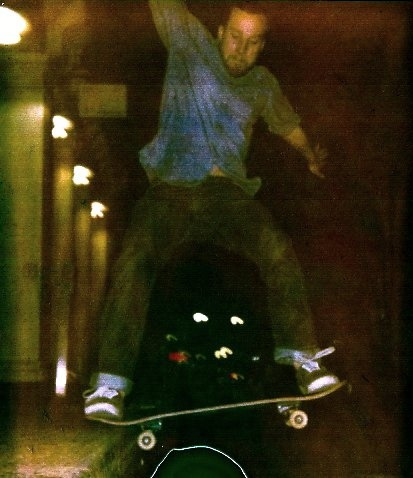Describe the objects in this image and their specific colors. I can see people in darkgreen, black, and gray tones and skateboard in darkgreen, black, olive, and gray tones in this image. 